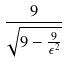Convert formula to latex. <formula><loc_0><loc_0><loc_500><loc_500>\frac { 9 } { \sqrt { 9 - \frac { 9 } { \epsilon ^ { 2 } } } }</formula> 